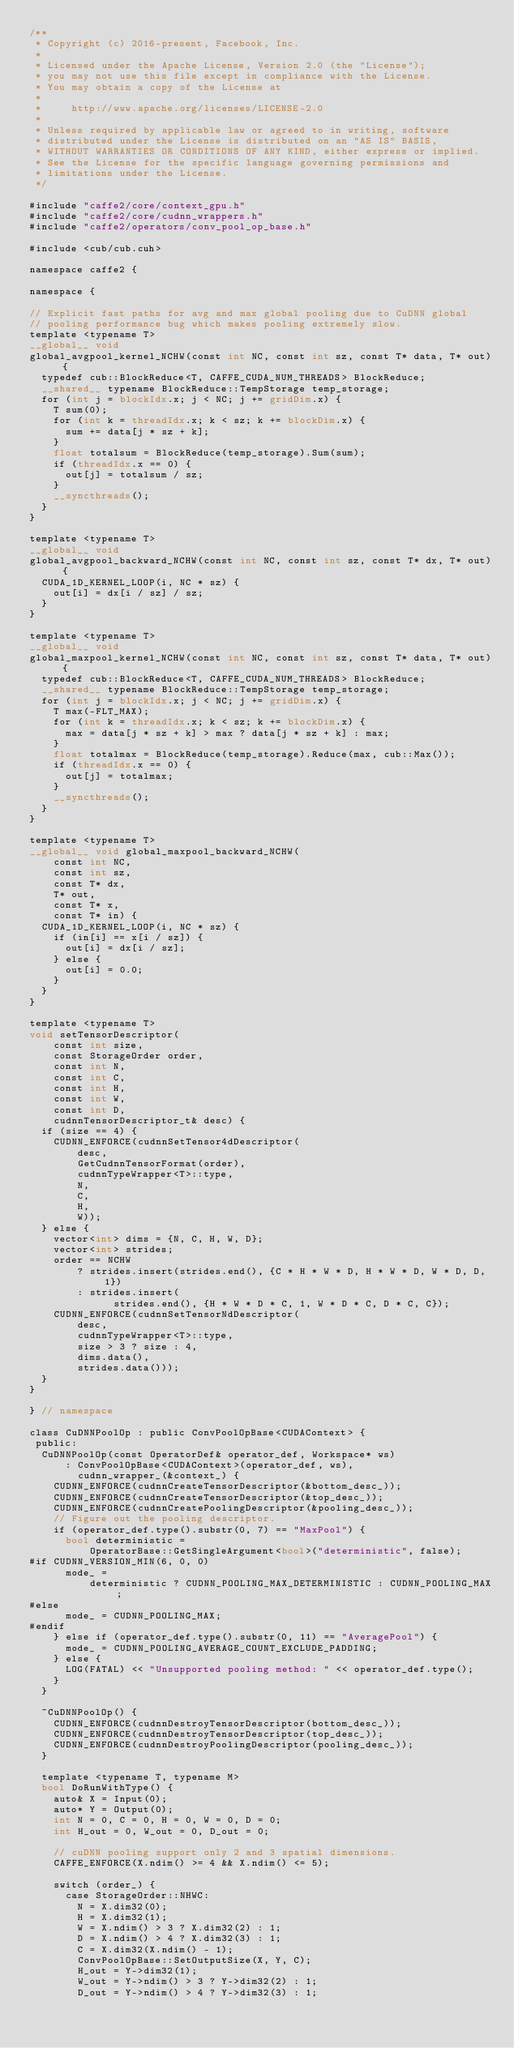<code> <loc_0><loc_0><loc_500><loc_500><_Cuda_>/**
 * Copyright (c) 2016-present, Facebook, Inc.
 *
 * Licensed under the Apache License, Version 2.0 (the "License");
 * you may not use this file except in compliance with the License.
 * You may obtain a copy of the License at
 *
 *     http://www.apache.org/licenses/LICENSE-2.0
 *
 * Unless required by applicable law or agreed to in writing, software
 * distributed under the License is distributed on an "AS IS" BASIS,
 * WITHOUT WARRANTIES OR CONDITIONS OF ANY KIND, either express or implied.
 * See the License for the specific language governing permissions and
 * limitations under the License.
 */

#include "caffe2/core/context_gpu.h"
#include "caffe2/core/cudnn_wrappers.h"
#include "caffe2/operators/conv_pool_op_base.h"

#include <cub/cub.cuh>

namespace caffe2 {

namespace {

// Explicit fast paths for avg and max global pooling due to CuDNN global
// pooling performance bug which makes pooling extremely slow.
template <typename T>
__global__ void
global_avgpool_kernel_NCHW(const int NC, const int sz, const T* data, T* out) {
  typedef cub::BlockReduce<T, CAFFE_CUDA_NUM_THREADS> BlockReduce;
  __shared__ typename BlockReduce::TempStorage temp_storage;
  for (int j = blockIdx.x; j < NC; j += gridDim.x) {
    T sum(0);
    for (int k = threadIdx.x; k < sz; k += blockDim.x) {
      sum += data[j * sz + k];
    }
    float totalsum = BlockReduce(temp_storage).Sum(sum);
    if (threadIdx.x == 0) {
      out[j] = totalsum / sz;
    }
    __syncthreads();
  }
}

template <typename T>
__global__ void
global_avgpool_backward_NCHW(const int NC, const int sz, const T* dx, T* out) {
  CUDA_1D_KERNEL_LOOP(i, NC * sz) {
    out[i] = dx[i / sz] / sz;
  }
}

template <typename T>
__global__ void
global_maxpool_kernel_NCHW(const int NC, const int sz, const T* data, T* out) {
  typedef cub::BlockReduce<T, CAFFE_CUDA_NUM_THREADS> BlockReduce;
  __shared__ typename BlockReduce::TempStorage temp_storage;
  for (int j = blockIdx.x; j < NC; j += gridDim.x) {
    T max(-FLT_MAX);
    for (int k = threadIdx.x; k < sz; k += blockDim.x) {
      max = data[j * sz + k] > max ? data[j * sz + k] : max;
    }
    float totalmax = BlockReduce(temp_storage).Reduce(max, cub::Max());
    if (threadIdx.x == 0) {
      out[j] = totalmax;
    }
    __syncthreads();
  }
}

template <typename T>
__global__ void global_maxpool_backward_NCHW(
    const int NC,
    const int sz,
    const T* dx,
    T* out,
    const T* x,
    const T* in) {
  CUDA_1D_KERNEL_LOOP(i, NC * sz) {
    if (in[i] == x[i / sz]) {
      out[i] = dx[i / sz];
    } else {
      out[i] = 0.0;
    }
  }
}

template <typename T>
void setTensorDescriptor(
    const int size,
    const StorageOrder order,
    const int N,
    const int C,
    const int H,
    const int W,
    const int D,
    cudnnTensorDescriptor_t& desc) {
  if (size == 4) {
    CUDNN_ENFORCE(cudnnSetTensor4dDescriptor(
        desc,
        GetCudnnTensorFormat(order),
        cudnnTypeWrapper<T>::type,
        N,
        C,
        H,
        W));
  } else {
    vector<int> dims = {N, C, H, W, D};
    vector<int> strides;
    order == NCHW
        ? strides.insert(strides.end(), {C * H * W * D, H * W * D, W * D, D, 1})
        : strides.insert(
              strides.end(), {H * W * D * C, 1, W * D * C, D * C, C});
    CUDNN_ENFORCE(cudnnSetTensorNdDescriptor(
        desc,
        cudnnTypeWrapper<T>::type,
        size > 3 ? size : 4,
        dims.data(),
        strides.data()));
  }
}

} // namespace

class CuDNNPoolOp : public ConvPoolOpBase<CUDAContext> {
 public:
  CuDNNPoolOp(const OperatorDef& operator_def, Workspace* ws)
      : ConvPoolOpBase<CUDAContext>(operator_def, ws),
        cudnn_wrapper_(&context_) {
    CUDNN_ENFORCE(cudnnCreateTensorDescriptor(&bottom_desc_));
    CUDNN_ENFORCE(cudnnCreateTensorDescriptor(&top_desc_));
    CUDNN_ENFORCE(cudnnCreatePoolingDescriptor(&pooling_desc_));
    // Figure out the pooling descriptor.
    if (operator_def.type().substr(0, 7) == "MaxPool") {
      bool deterministic =
          OperatorBase::GetSingleArgument<bool>("deterministic", false);
#if CUDNN_VERSION_MIN(6, 0, 0)
      mode_ =
          deterministic ? CUDNN_POOLING_MAX_DETERMINISTIC : CUDNN_POOLING_MAX;
#else
      mode_ = CUDNN_POOLING_MAX;
#endif
    } else if (operator_def.type().substr(0, 11) == "AveragePool") {
      mode_ = CUDNN_POOLING_AVERAGE_COUNT_EXCLUDE_PADDING;
    } else {
      LOG(FATAL) << "Unsupported pooling method: " << operator_def.type();
    }
  }

  ~CuDNNPoolOp() {
    CUDNN_ENFORCE(cudnnDestroyTensorDescriptor(bottom_desc_));
    CUDNN_ENFORCE(cudnnDestroyTensorDescriptor(top_desc_));
    CUDNN_ENFORCE(cudnnDestroyPoolingDescriptor(pooling_desc_));
  }

  template <typename T, typename M>
  bool DoRunWithType() {
    auto& X = Input(0);
    auto* Y = Output(0);
    int N = 0, C = 0, H = 0, W = 0, D = 0;
    int H_out = 0, W_out = 0, D_out = 0;

    // cuDNN pooling support only 2 and 3 spatial dimensions.
    CAFFE_ENFORCE(X.ndim() >= 4 && X.ndim() <= 5);

    switch (order_) {
      case StorageOrder::NHWC:
        N = X.dim32(0);
        H = X.dim32(1);
        W = X.ndim() > 3 ? X.dim32(2) : 1;
        D = X.ndim() > 4 ? X.dim32(3) : 1;
        C = X.dim32(X.ndim() - 1);
        ConvPoolOpBase::SetOutputSize(X, Y, C);
        H_out = Y->dim32(1);
        W_out = Y->ndim() > 3 ? Y->dim32(2) : 1;
        D_out = Y->ndim() > 4 ? Y->dim32(3) : 1;</code> 